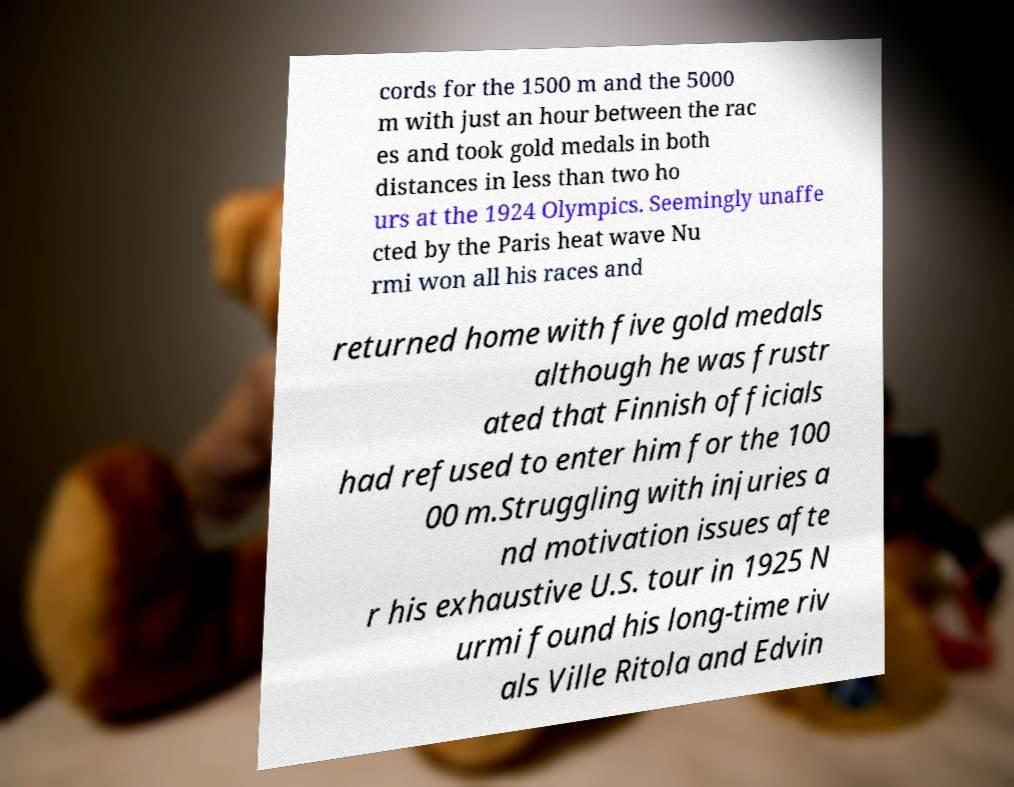Could you extract and type out the text from this image? cords for the 1500 m and the 5000 m with just an hour between the rac es and took gold medals in both distances in less than two ho urs at the 1924 Olympics. Seemingly unaffe cted by the Paris heat wave Nu rmi won all his races and returned home with five gold medals although he was frustr ated that Finnish officials had refused to enter him for the 100 00 m.Struggling with injuries a nd motivation issues afte r his exhaustive U.S. tour in 1925 N urmi found his long-time riv als Ville Ritola and Edvin 